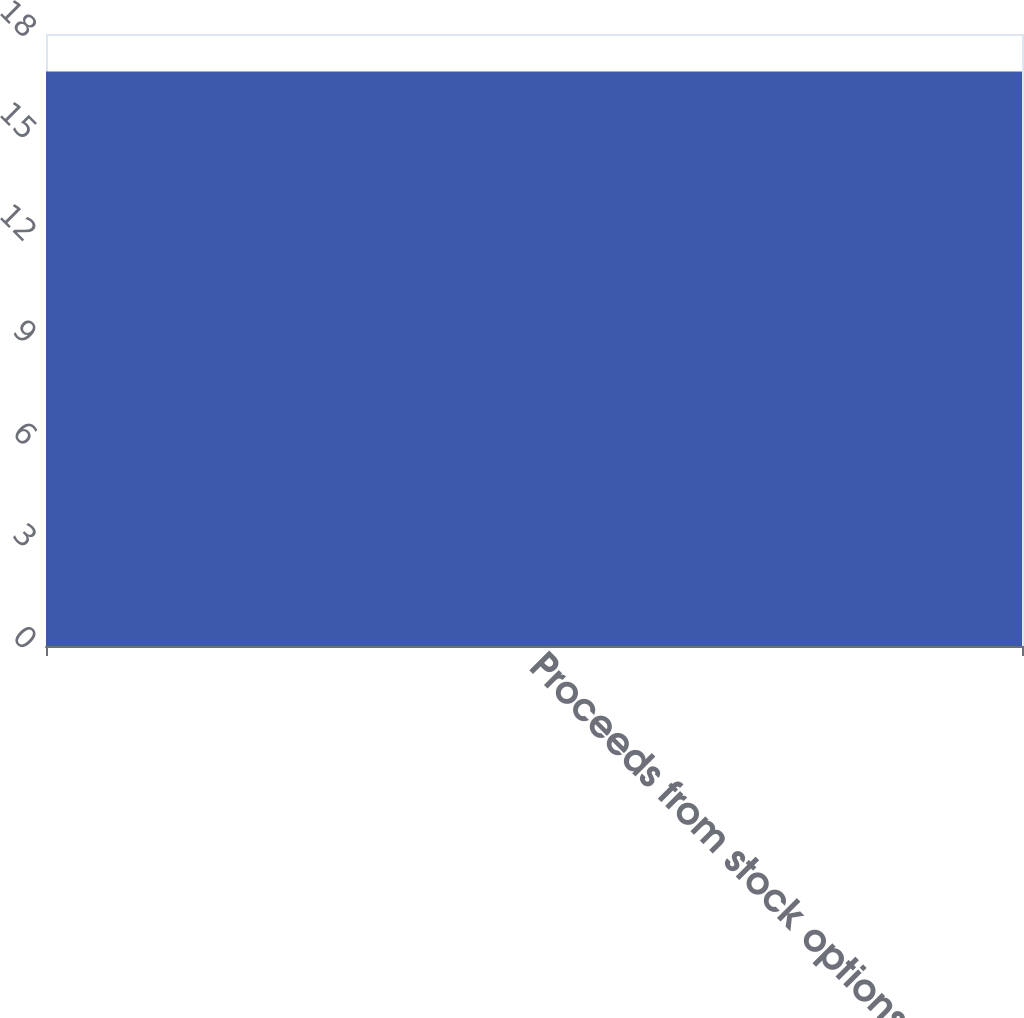<chart> <loc_0><loc_0><loc_500><loc_500><bar_chart><fcel>Proceeds from stock options<nl><fcel>16.9<nl></chart> 